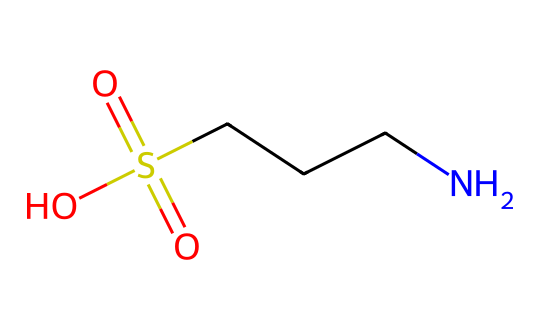What is the total number of carbon atoms in taurine? In the given SMILES representation, there are two 'C' characters, which represent the carbon atoms in the molecule. Therefore, counting these gives a total of two carbon atoms.
Answer: 2 How many nitrogen atoms are present in the structure of taurine? The 'N' character in the SMILES representation indicates the presence of one nitrogen atom. As there is only one 'N', it confirms there is just one nitrogen atom.
Answer: 1 What type of functional group is represented by the -SO₃H in taurine? The presence of -SO₃H indicates a sulfonic acid group, which is characterized by the sulfur atom double-bonded to two oxygen atoms and single-bonded to a hydroxyl group. This reveals the functional group type.
Answer: sulfonic acid Which atom in taurine contributes to its zwitterionic nature? The nitrogen atom ('N') in taurine carries a positive charge, while the sulfonic acid group can donate a proton to create a negatively charged site. This dual charge character creates a zwitterion.
Answer: nitrogen What is the oxidation state of sulfur in taurine? Sulfur is connected to four oxygens (two through double bonds and one through a single bond plus another hydroxyl group), determining its oxidation state. The oxidation state can be calculated to be +6.
Answer: +6 How many total oxygen atoms are present in taurine? In the structure, there are three 'O' characters visible, which represent three oxygen atoms in total. Thus when counted, the total number of oxygen atoms is three.
Answer: 3 